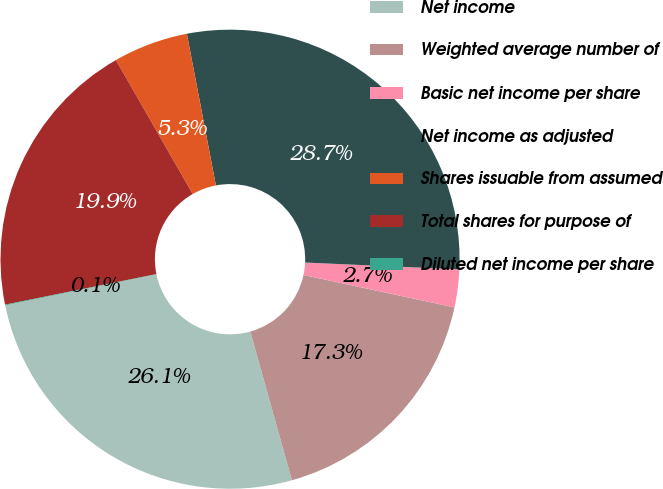Convert chart. <chart><loc_0><loc_0><loc_500><loc_500><pie_chart><fcel>Net income<fcel>Weighted average number of<fcel>Basic net income per share<fcel>Net income as adjusted<fcel>Shares issuable from assumed<fcel>Total shares for purpose of<fcel>Diluted net income per share<nl><fcel>26.12%<fcel>17.29%<fcel>2.66%<fcel>28.72%<fcel>5.27%<fcel>19.89%<fcel>0.05%<nl></chart> 